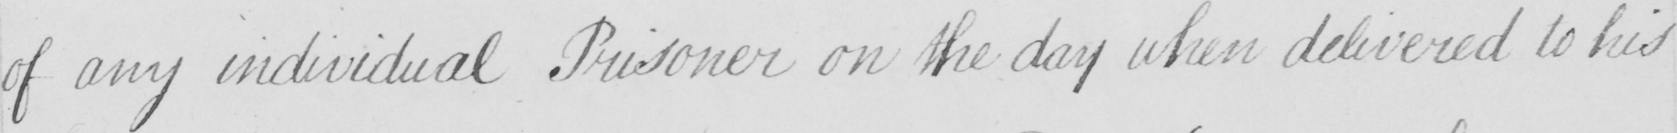Can you tell me what this handwritten text says? of any individual Prisoner on the day which delivered to his 